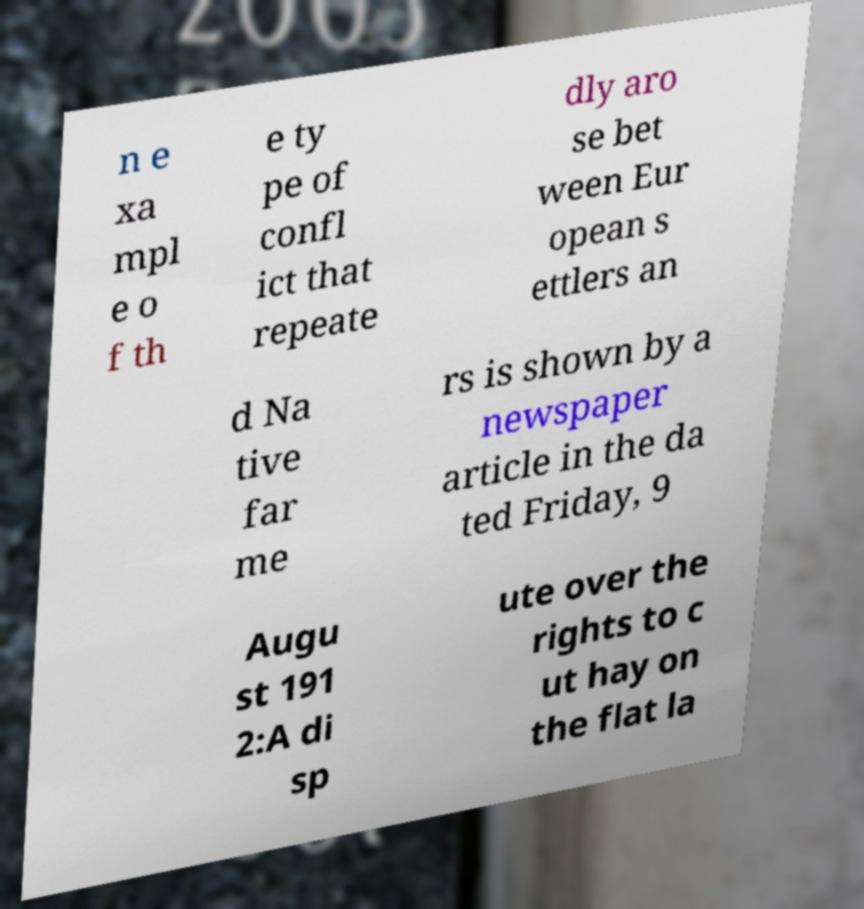Can you read and provide the text displayed in the image?This photo seems to have some interesting text. Can you extract and type it out for me? n e xa mpl e o f th e ty pe of confl ict that repeate dly aro se bet ween Eur opean s ettlers an d Na tive far me rs is shown by a newspaper article in the da ted Friday, 9 Augu st 191 2:A di sp ute over the rights to c ut hay on the flat la 